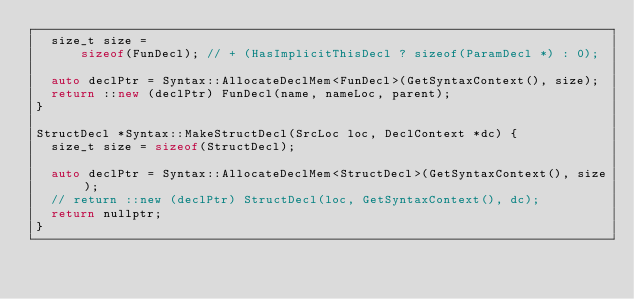Convert code to text. <code><loc_0><loc_0><loc_500><loc_500><_C++_>  size_t size =
      sizeof(FunDecl); // + (HasImplicitThisDecl ? sizeof(ParamDecl *) : 0);

  auto declPtr = Syntax::AllocateDeclMem<FunDecl>(GetSyntaxContext(), size);
  return ::new (declPtr) FunDecl(name, nameLoc, parent);
}

StructDecl *Syntax::MakeStructDecl(SrcLoc loc, DeclContext *dc) {
  size_t size = sizeof(StructDecl);

  auto declPtr = Syntax::AllocateDeclMem<StructDecl>(GetSyntaxContext(), size);
  // return ::new (declPtr) StructDecl(loc, GetSyntaxContext(), dc);
  return nullptr;
}</code> 